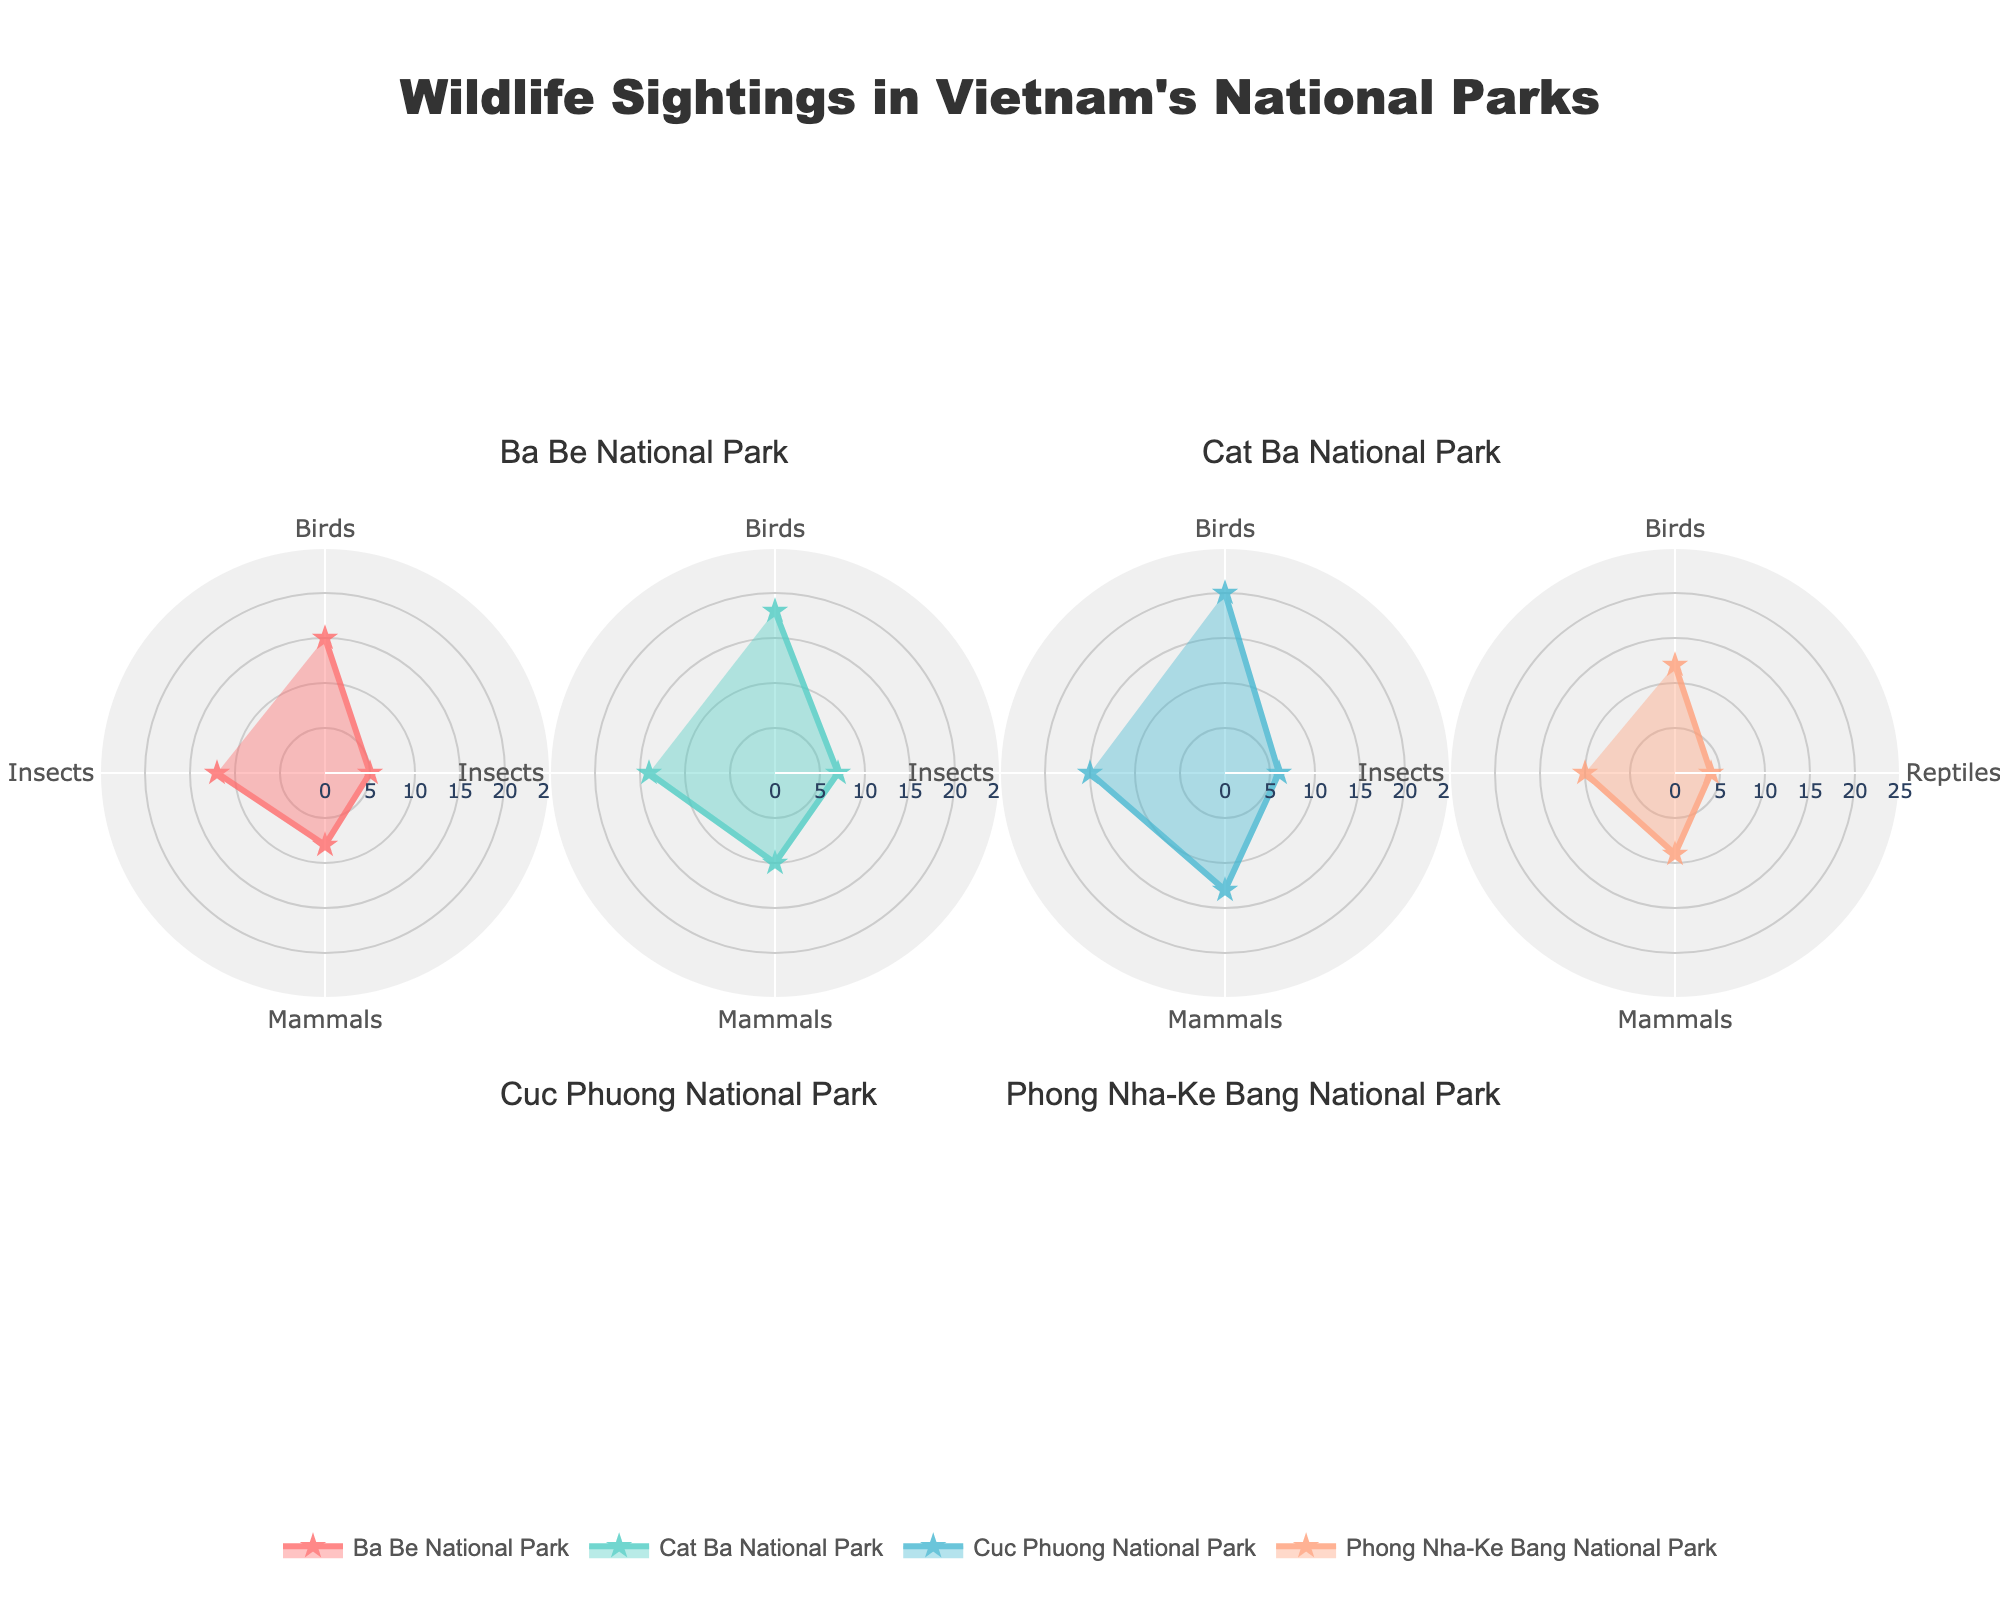What is the highest frequency of bird sightings and in which park? To find the park with the highest frequency of bird sightings, look at each subplot and note the bird sighting frequencies. Cuc Phuong National Park shows the highest frequency at 20.
Answer: Cuc Phuong National Park (20) Which park has the lowest frequency of reptile sightings? Compare the frequencies of reptile sightings across all subplots. Phong Nha-Ke Bang National Park has the lowest frequency at 4.
Answer: Phong Nha-Ke Bang National Park (4) What’s the total frequency of mammal sightings across all parks? Sum the mammal sightings from each park: Ba Be (8), Cat Ba (10), Cuc Phuong (13), and Phong Nha-Ke Bang (9). 8 + 10 + 13 + 9 = 40.
Answer: 40 Which type of wildlife has the overall highest frequency in Cat Ba National Park? Observe the frequencies in Cat Ba for each type: Birds (18), Reptiles (7), Mammals (10), Insects (14). The highest is Birds with 18.
Answer: Birds (18) Comparing insect sightings, which park has the fewest sightings? Look at the frequency of insect sightings in each subplot: Ba Be (12), Cat Ba (14), Cuc Phuong (15), and Phong Nha-Ke Bang (10). Phong Nha-Ke Bang has the fewest with 10.
Answer: Phong Nha-Ke Bang National Park (10) How many parks have bird sightings that exceed 15? Check each park's bird sighting frequency: Ba Be (15), Cat Ba (18), Cuc Phuong (20), Phong Nha-Ke Bang (12). Cat Ba and Cuc Phuong exceed 15.
Answer: 2 What is the average frequency of reptile sightings across all parks? Sum the reptile sightings from all parks: Ba Be (5), Cat Ba (7), Cuc Phuong (6), Phong Nha-Ke Bang (4). Divide by the number of data points: (5 + 7 + 6 + 4) / 4 = 5.5.
Answer: 5.5 In which park are the insect sightings and mammal sightings equal? Compare the frequencies of insect and mammal sightings in each park: Ba Be (12, 8), Cat Ba (14, 10), Cuc Phuong (15, 13), Phong Nha-Ke Bang (10, 9). None of the parks have equal frequencies.
Answer: None 